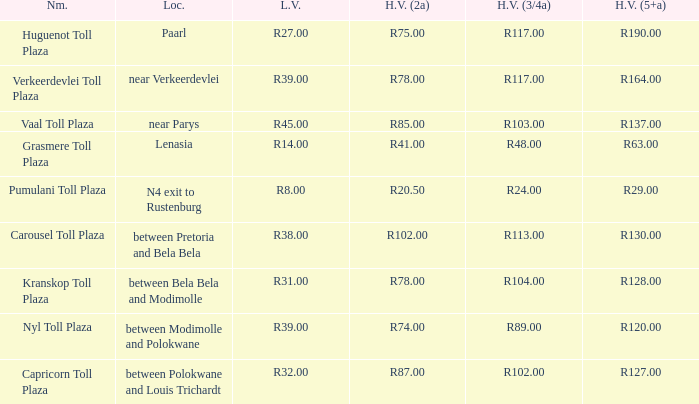What is the title of the square where the fee for large vehicles with 2 axles is r2 Pumulani Toll Plaza. 